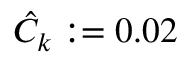<formula> <loc_0><loc_0><loc_500><loc_500>\hat { C } _ { k } \colon = 0 . 0 2</formula> 